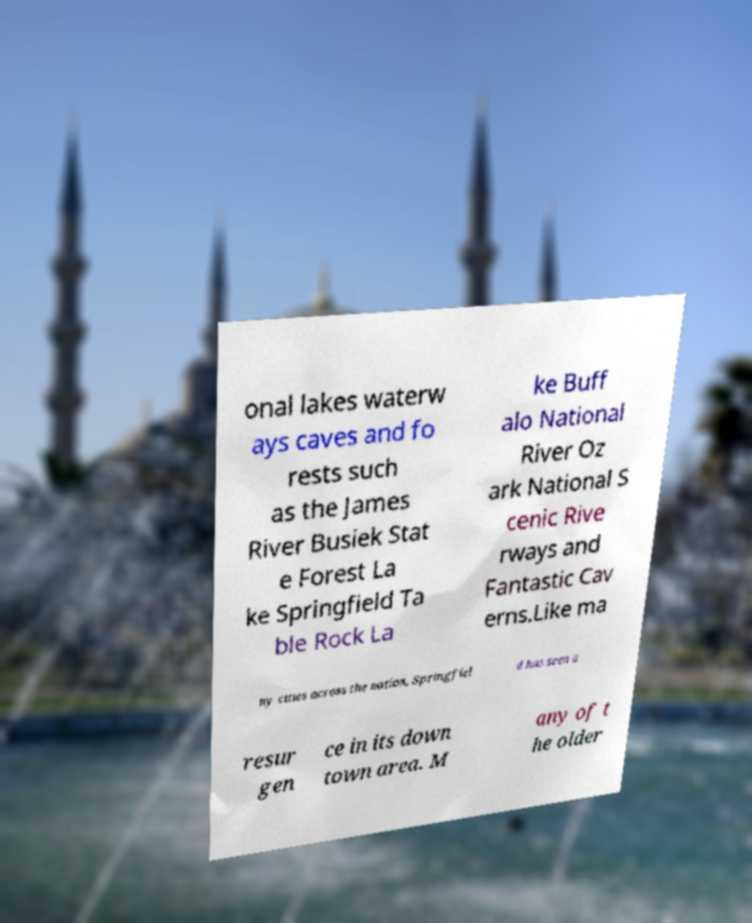Can you accurately transcribe the text from the provided image for me? onal lakes waterw ays caves and fo rests such as the James River Busiek Stat e Forest La ke Springfield Ta ble Rock La ke Buff alo National River Oz ark National S cenic Rive rways and Fantastic Cav erns.Like ma ny cities across the nation, Springfiel d has seen a resur gen ce in its down town area. M any of t he older 